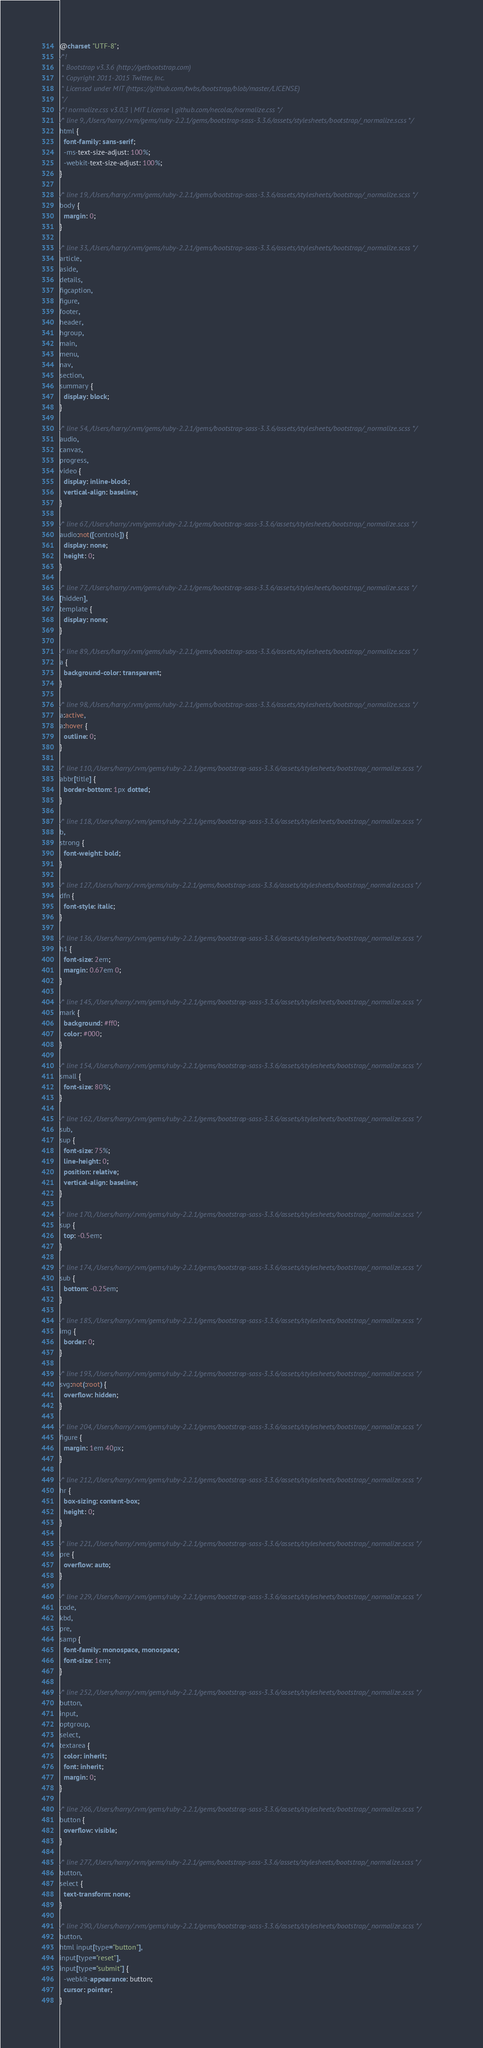<code> <loc_0><loc_0><loc_500><loc_500><_CSS_>@charset "UTF-8";
/*!
 * Bootstrap v3.3.6 (http://getbootstrap.com)
 * Copyright 2011-2015 Twitter, Inc.
 * Licensed under MIT (https://github.com/twbs/bootstrap/blob/master/LICENSE)
 */
/*! normalize.css v3.0.3 | MIT License | github.com/necolas/normalize.css */
/* line 9, /Users/harry/.rvm/gems/ruby-2.2.1/gems/bootstrap-sass-3.3.6/assets/stylesheets/bootstrap/_normalize.scss */
html {
  font-family: sans-serif;
  -ms-text-size-adjust: 100%;
  -webkit-text-size-adjust: 100%;
}

/* line 19, /Users/harry/.rvm/gems/ruby-2.2.1/gems/bootstrap-sass-3.3.6/assets/stylesheets/bootstrap/_normalize.scss */
body {
  margin: 0;
}

/* line 33, /Users/harry/.rvm/gems/ruby-2.2.1/gems/bootstrap-sass-3.3.6/assets/stylesheets/bootstrap/_normalize.scss */
article,
aside,
details,
figcaption,
figure,
footer,
header,
hgroup,
main,
menu,
nav,
section,
summary {
  display: block;
}

/* line 54, /Users/harry/.rvm/gems/ruby-2.2.1/gems/bootstrap-sass-3.3.6/assets/stylesheets/bootstrap/_normalize.scss */
audio,
canvas,
progress,
video {
  display: inline-block;
  vertical-align: baseline;
}

/* line 67, /Users/harry/.rvm/gems/ruby-2.2.1/gems/bootstrap-sass-3.3.6/assets/stylesheets/bootstrap/_normalize.scss */
audio:not([controls]) {
  display: none;
  height: 0;
}

/* line 77, /Users/harry/.rvm/gems/ruby-2.2.1/gems/bootstrap-sass-3.3.6/assets/stylesheets/bootstrap/_normalize.scss */
[hidden],
template {
  display: none;
}

/* line 89, /Users/harry/.rvm/gems/ruby-2.2.1/gems/bootstrap-sass-3.3.6/assets/stylesheets/bootstrap/_normalize.scss */
a {
  background-color: transparent;
}

/* line 98, /Users/harry/.rvm/gems/ruby-2.2.1/gems/bootstrap-sass-3.3.6/assets/stylesheets/bootstrap/_normalize.scss */
a:active,
a:hover {
  outline: 0;
}

/* line 110, /Users/harry/.rvm/gems/ruby-2.2.1/gems/bootstrap-sass-3.3.6/assets/stylesheets/bootstrap/_normalize.scss */
abbr[title] {
  border-bottom: 1px dotted;
}

/* line 118, /Users/harry/.rvm/gems/ruby-2.2.1/gems/bootstrap-sass-3.3.6/assets/stylesheets/bootstrap/_normalize.scss */
b,
strong {
  font-weight: bold;
}

/* line 127, /Users/harry/.rvm/gems/ruby-2.2.1/gems/bootstrap-sass-3.3.6/assets/stylesheets/bootstrap/_normalize.scss */
dfn {
  font-style: italic;
}

/* line 136, /Users/harry/.rvm/gems/ruby-2.2.1/gems/bootstrap-sass-3.3.6/assets/stylesheets/bootstrap/_normalize.scss */
h1 {
  font-size: 2em;
  margin: 0.67em 0;
}

/* line 145, /Users/harry/.rvm/gems/ruby-2.2.1/gems/bootstrap-sass-3.3.6/assets/stylesheets/bootstrap/_normalize.scss */
mark {
  background: #ff0;
  color: #000;
}

/* line 154, /Users/harry/.rvm/gems/ruby-2.2.1/gems/bootstrap-sass-3.3.6/assets/stylesheets/bootstrap/_normalize.scss */
small {
  font-size: 80%;
}

/* line 162, /Users/harry/.rvm/gems/ruby-2.2.1/gems/bootstrap-sass-3.3.6/assets/stylesheets/bootstrap/_normalize.scss */
sub,
sup {
  font-size: 75%;
  line-height: 0;
  position: relative;
  vertical-align: baseline;
}

/* line 170, /Users/harry/.rvm/gems/ruby-2.2.1/gems/bootstrap-sass-3.3.6/assets/stylesheets/bootstrap/_normalize.scss */
sup {
  top: -0.5em;
}

/* line 174, /Users/harry/.rvm/gems/ruby-2.2.1/gems/bootstrap-sass-3.3.6/assets/stylesheets/bootstrap/_normalize.scss */
sub {
  bottom: -0.25em;
}

/* line 185, /Users/harry/.rvm/gems/ruby-2.2.1/gems/bootstrap-sass-3.3.6/assets/stylesheets/bootstrap/_normalize.scss */
img {
  border: 0;
}

/* line 193, /Users/harry/.rvm/gems/ruby-2.2.1/gems/bootstrap-sass-3.3.6/assets/stylesheets/bootstrap/_normalize.scss */
svg:not(:root) {
  overflow: hidden;
}

/* line 204, /Users/harry/.rvm/gems/ruby-2.2.1/gems/bootstrap-sass-3.3.6/assets/stylesheets/bootstrap/_normalize.scss */
figure {
  margin: 1em 40px;
}

/* line 212, /Users/harry/.rvm/gems/ruby-2.2.1/gems/bootstrap-sass-3.3.6/assets/stylesheets/bootstrap/_normalize.scss */
hr {
  box-sizing: content-box;
  height: 0;
}

/* line 221, /Users/harry/.rvm/gems/ruby-2.2.1/gems/bootstrap-sass-3.3.6/assets/stylesheets/bootstrap/_normalize.scss */
pre {
  overflow: auto;
}

/* line 229, /Users/harry/.rvm/gems/ruby-2.2.1/gems/bootstrap-sass-3.3.6/assets/stylesheets/bootstrap/_normalize.scss */
code,
kbd,
pre,
samp {
  font-family: monospace, monospace;
  font-size: 1em;
}

/* line 252, /Users/harry/.rvm/gems/ruby-2.2.1/gems/bootstrap-sass-3.3.6/assets/stylesheets/bootstrap/_normalize.scss */
button,
input,
optgroup,
select,
textarea {
  color: inherit;
  font: inherit;
  margin: 0;
}

/* line 266, /Users/harry/.rvm/gems/ruby-2.2.1/gems/bootstrap-sass-3.3.6/assets/stylesheets/bootstrap/_normalize.scss */
button {
  overflow: visible;
}

/* line 277, /Users/harry/.rvm/gems/ruby-2.2.1/gems/bootstrap-sass-3.3.6/assets/stylesheets/bootstrap/_normalize.scss */
button,
select {
  text-transform: none;
}

/* line 290, /Users/harry/.rvm/gems/ruby-2.2.1/gems/bootstrap-sass-3.3.6/assets/stylesheets/bootstrap/_normalize.scss */
button,
html input[type="button"],
input[type="reset"],
input[type="submit"] {
  -webkit-appearance: button;
  cursor: pointer;
}
</code> 